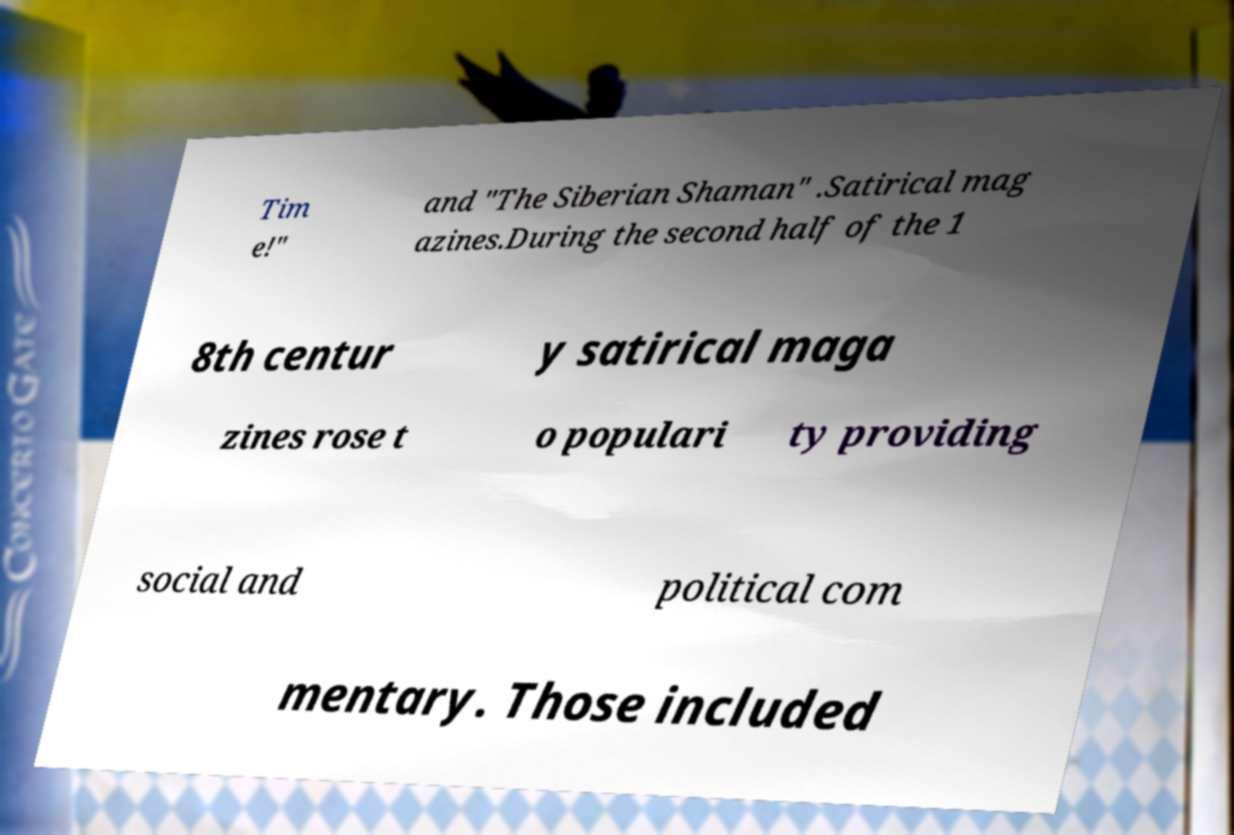I need the written content from this picture converted into text. Can you do that? Tim e!" and "The Siberian Shaman" .Satirical mag azines.During the second half of the 1 8th centur y satirical maga zines rose t o populari ty providing social and political com mentary. Those included 